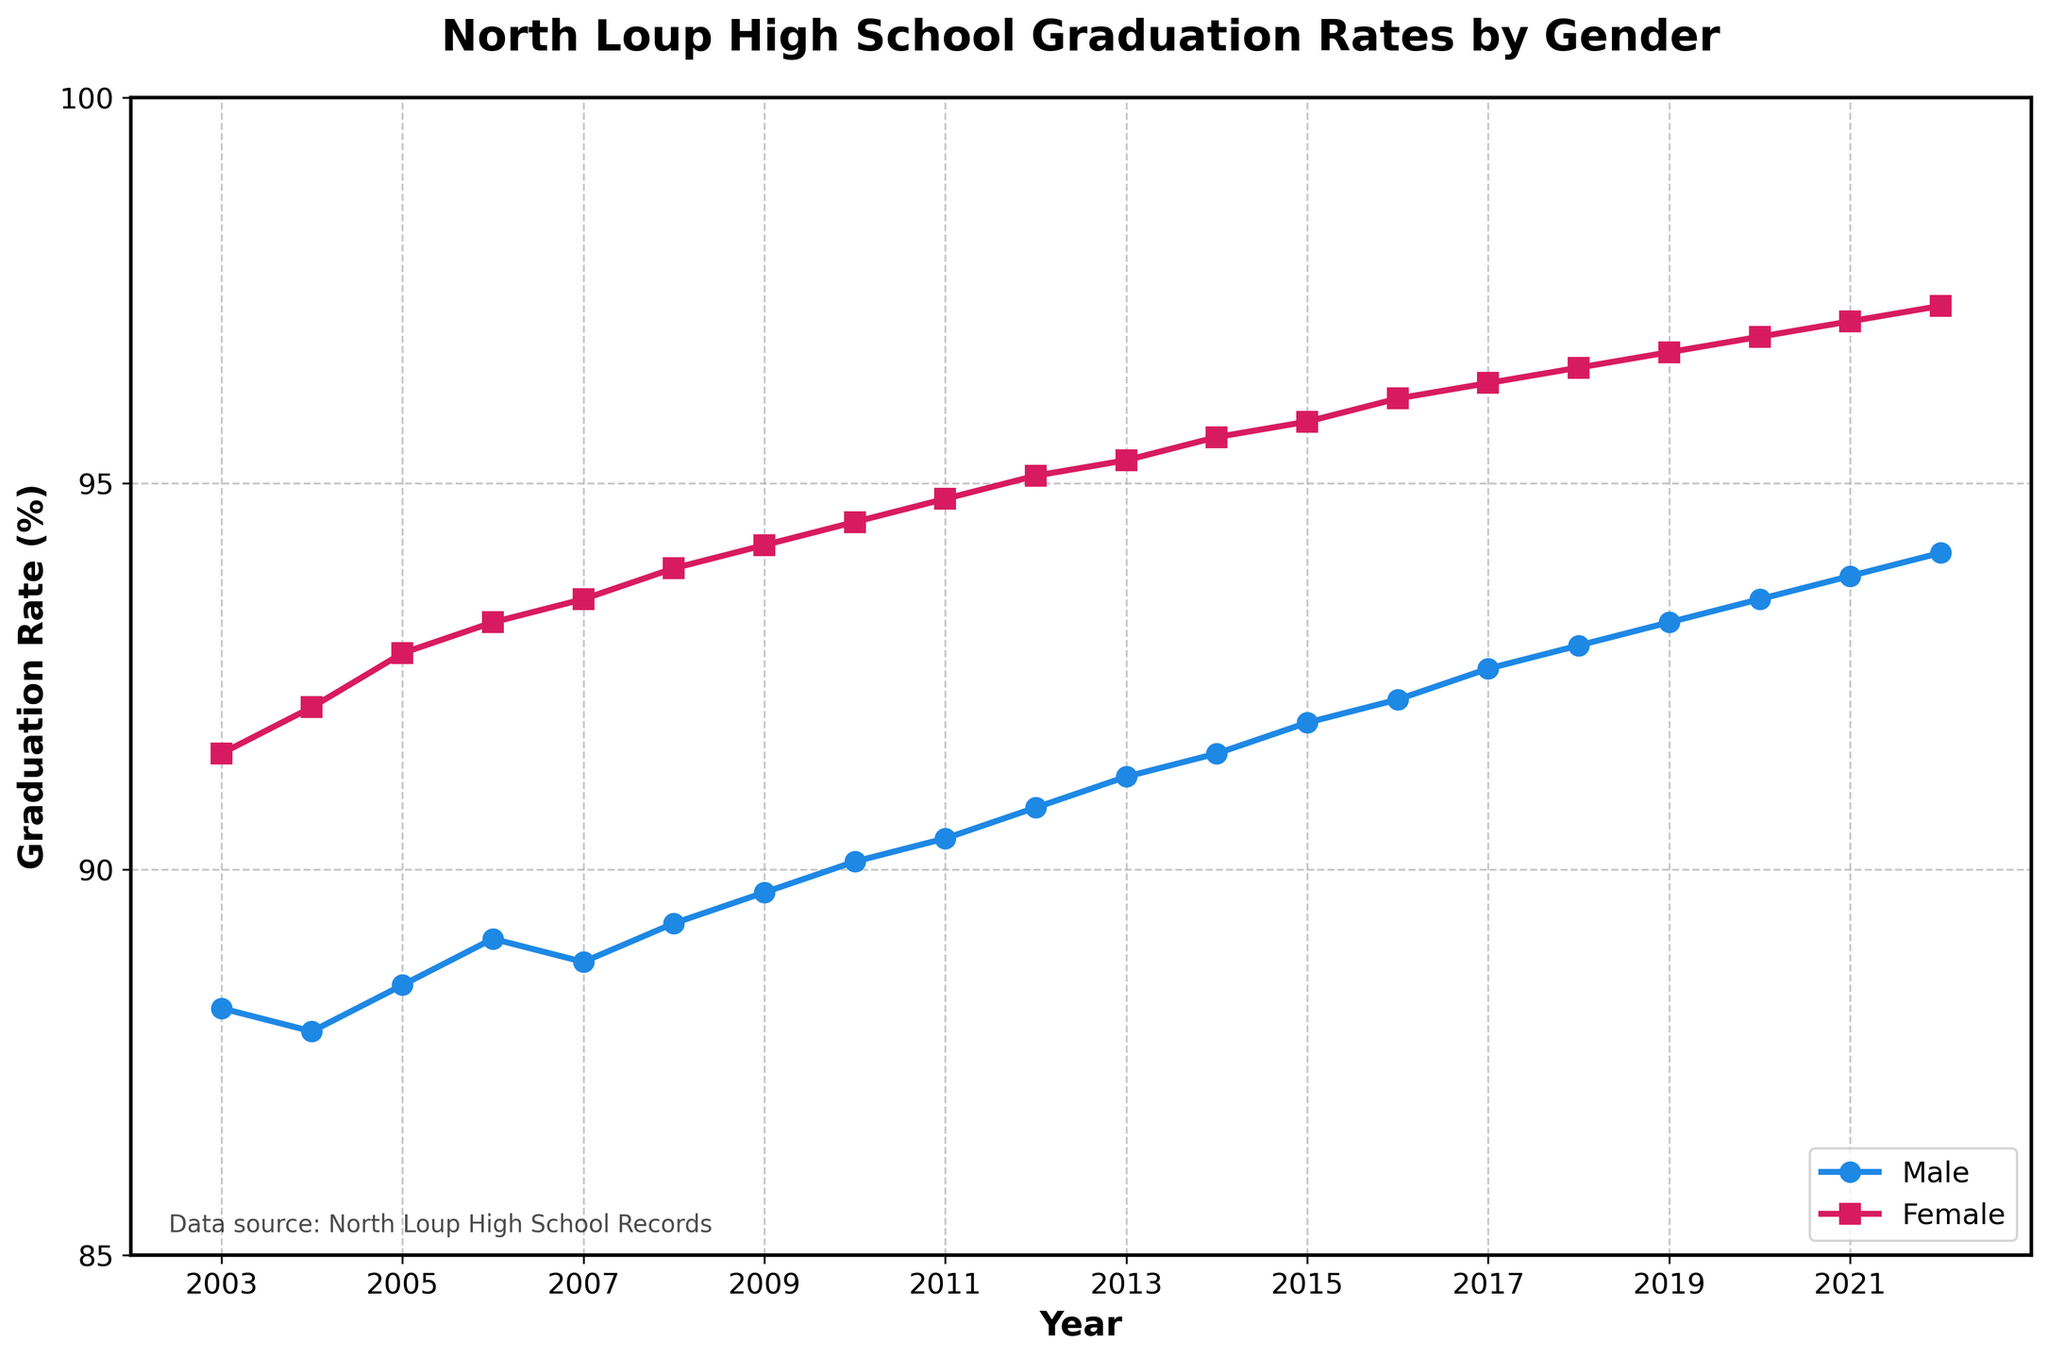What trend do you notice in the graduation rates for males over the 20-year period? The graduation rates for males have shown a steady increase from 88.2% in 2003 to 94.1% in 2022. This indicates a consistent improvement in male graduation rates over the years.
Answer: Steady increase How do the female graduation rates in 2022 compare to those in 2003? In 2003, the female graduation rate was 91.5%. By 2022, it had risen to 97.3%. This shows an increase of 5.8 percentage points.
Answer: Increased by 5.8 percentage points What's the average graduation rate for males over the 20-year period? To find the average, sum up all the male graduation rates from 2003 to 2022 and then divide by the number of years (20). The sum is 1,828.2, and when divided by 20, the average is 91.41%.
Answer: 91.41% Which year had the largest gender gap in graduation rates? The largest gender gap occurred in 2008, with males at 89.3% and females at 93.9%, resulting in a gap of 4.6 percentage points.
Answer: 2008 Has there been any year where the male graduation rate decreased compared to the previous year? Yes, the male graduation rate decreased slightly from 88.2% in 2003 to 87.9% in 2004.
Answer: 2004 Which gender had the higher graduation rate in 2015, and by how much? In 2015, females had a higher graduation rate (95.8%) compared to males (91.9%). The difference is 3.9 percentage points.
Answer: Females by 3.9% What's the total increase in graduation rates for males from 2003 to 2022? The increase in male graduation rates from 2003 (88.2%) to 2022 (94.1%) is 5.9 percentage points.
Answer: 5.9 percentage points Calculate the average annual increase in female graduation rates from 2003 to 2022. To find the average annual increase: (97.3% - 91.5%) over 19 years (2022 - 2003), which gives 5.8% / 19 = 0.305%.
Answer: 0.305% During which periods did both male and female graduation rates show the same upward trend? Both male and female graduation rates showed a continuous upward trend from 2005 until 2022.
Answer: 2005 to 2022 Are there any visually distinct patterns between the male and female graduation rates? Yes, the female graduation rates are consistently higher and show a slightly steeper upward trend compared to male rates, with males starting closer to 88% and females closer to 91.5%, but both showing improvement over time.
Answer: Females consistently higher, steeper upward trend 